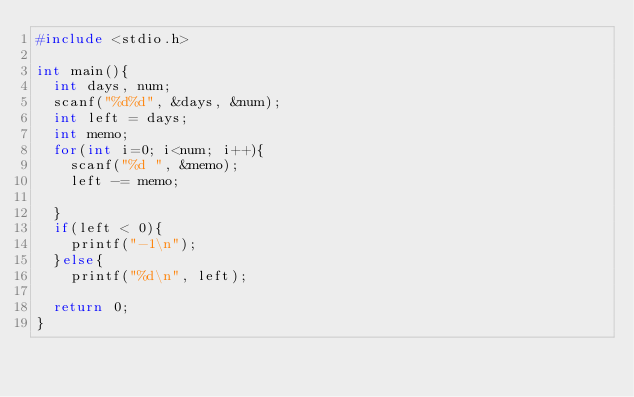Convert code to text. <code><loc_0><loc_0><loc_500><loc_500><_C_>#include <stdio.h>

int main(){
  int days, num;
  scanf("%d%d", &days, &num);
  int left = days;
  int memo;
  for(int i=0; i<num; i++){
    scanf("%d ", &memo);
    left -= memo;
    
  }
  if(left < 0){
    printf("-1\n");
  }else{
    printf("%d\n", left);
  
  return 0;
}</code> 